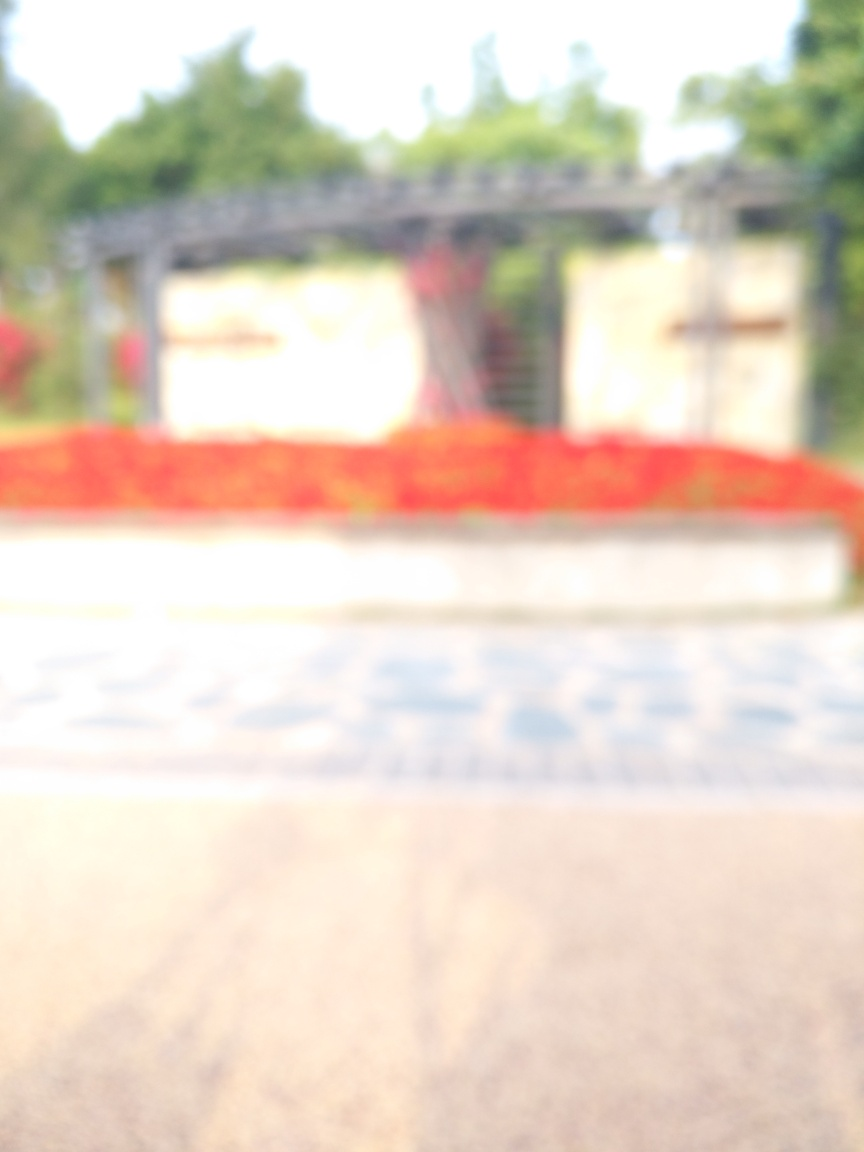Is the overall sharpness of the image low?
 Yes 